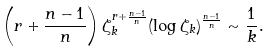<formula> <loc_0><loc_0><loc_500><loc_500>\left ( r + \frac { n - 1 } { n } \right ) \zeta _ { k } ^ { r + \frac { n - 1 } { n } } ( \log \zeta _ { k } ) ^ { \frac { n - 1 } { n } } \sim \frac { 1 } { k } .</formula> 